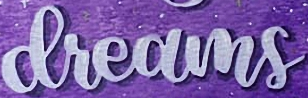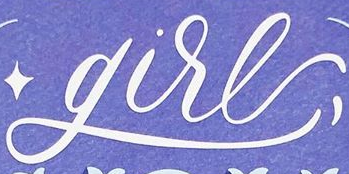Transcribe the words shown in these images in order, separated by a semicolon. dreams; gire 